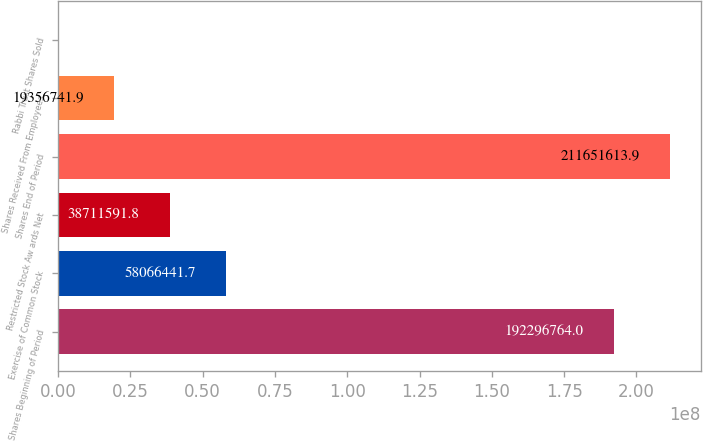<chart> <loc_0><loc_0><loc_500><loc_500><bar_chart><fcel>Shares Beginning of Period<fcel>Exercise of Common Stock<fcel>Restricted Stock Aw ards Net<fcel>Shares End of Period<fcel>Shares Received From Employees<fcel>Rabbi Trust Shares Sold<nl><fcel>1.92297e+08<fcel>5.80664e+07<fcel>3.87116e+07<fcel>2.11652e+08<fcel>1.93567e+07<fcel>1892<nl></chart> 